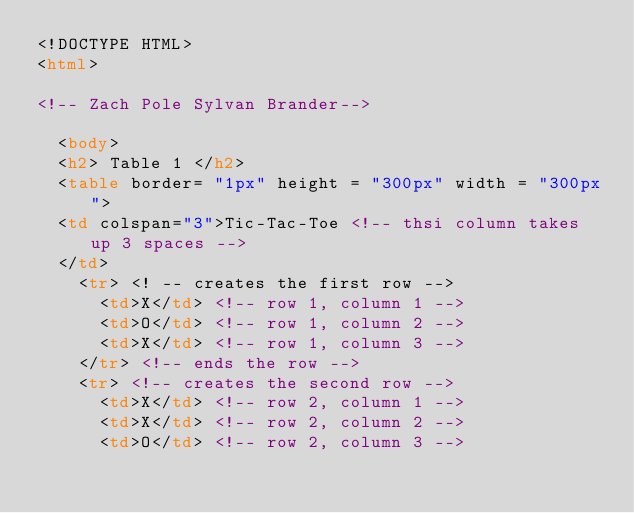<code> <loc_0><loc_0><loc_500><loc_500><_HTML_><!DOCTYPE HTML>
<html>

<!-- Zach Pole Sylvan Brander-->

	<body>
	<h2> Table 1 </h2>
	<table border= "1px" height = "300px" width = "300px">
	<td colspan="3">Tic-Tac-Toe <!-- thsi column takes up 3 spaces -->
	</td>
		<tr> <! -- creates the first row -->
			<td>X</td> <!-- row 1, column 1 -->
			<td>O</td> <!-- row 1, column 2 -->
			<td>X</td> <!-- row 1, column 3 -->
		</tr> <!-- ends the row -->
		<tr> <!-- creates the second row -->
			<td>X</td> <!-- row 2, column 1 -->
			<td>X</td> <!-- row 2, column 2 -->
			<td>O</td> <!-- row 2, column 3 --></code> 